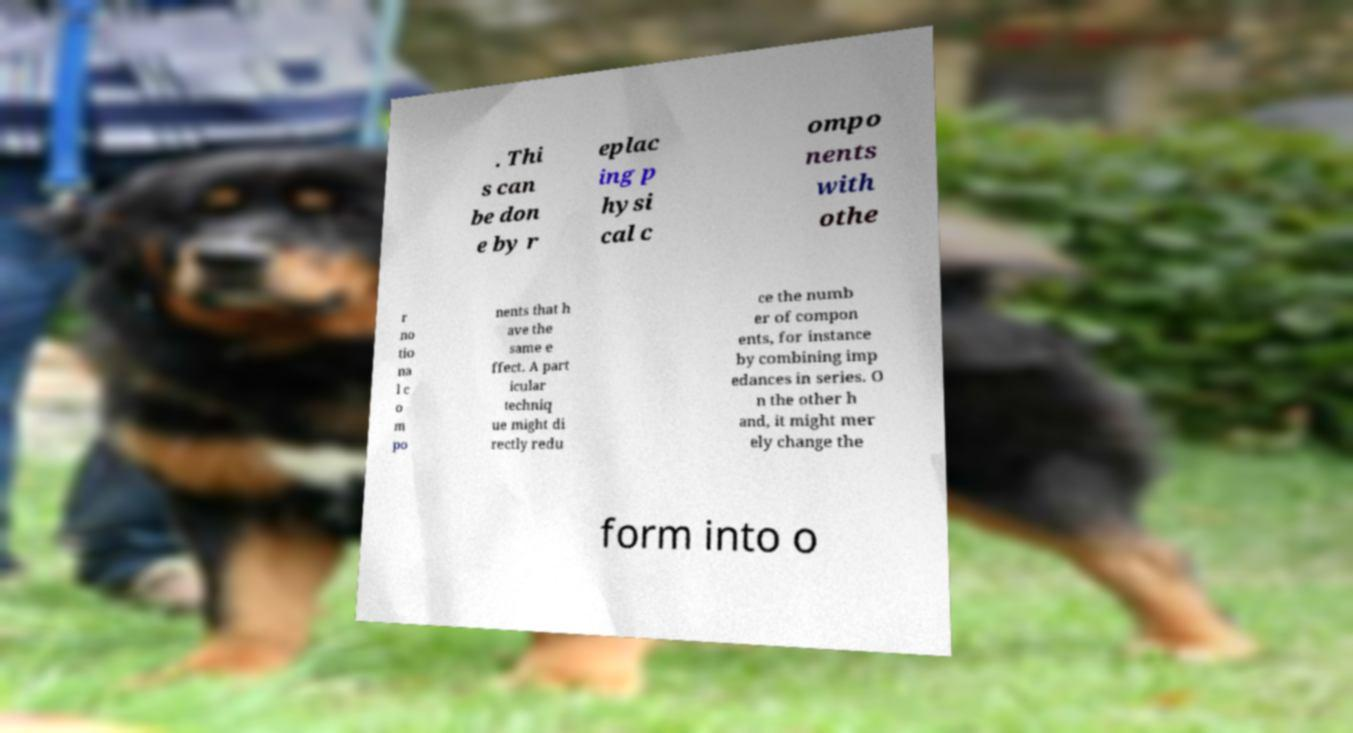Could you extract and type out the text from this image? . Thi s can be don e by r eplac ing p hysi cal c ompo nents with othe r no tio na l c o m po nents that h ave the same e ffect. A part icular techniq ue might di rectly redu ce the numb er of compon ents, for instance by combining imp edances in series. O n the other h and, it might mer ely change the form into o 